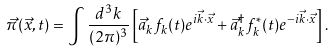<formula> <loc_0><loc_0><loc_500><loc_500>\vec { \pi } ( \vec { x } , t ) = \int \frac { d ^ { 3 } k } { ( 2 \pi ) ^ { 3 } } \left [ { \vec { a } } _ { k } f _ { k } ( t ) e ^ { i \vec { k } \cdot \vec { x } } + { \vec { a } } ^ { \dagger } _ { k } f ^ { * } _ { k } ( t ) e ^ { - i \vec { k } \cdot \vec { x } } \right ] .</formula> 